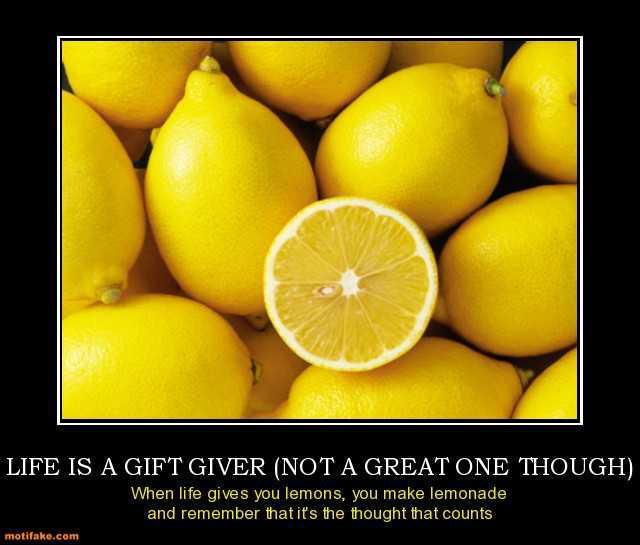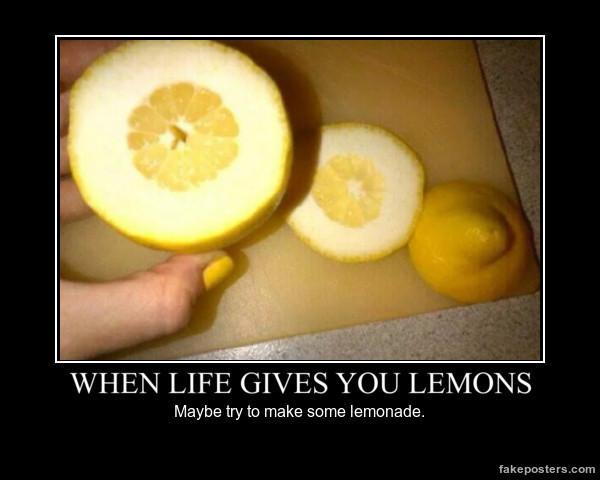The first image is the image on the left, the second image is the image on the right. For the images shown, is this caption "There are more than two whole lemons." true? Answer yes or no. Yes. The first image is the image on the left, the second image is the image on the right. Analyze the images presented: Is the assertion "There are at least 8 lemons." valid? Answer yes or no. Yes. 